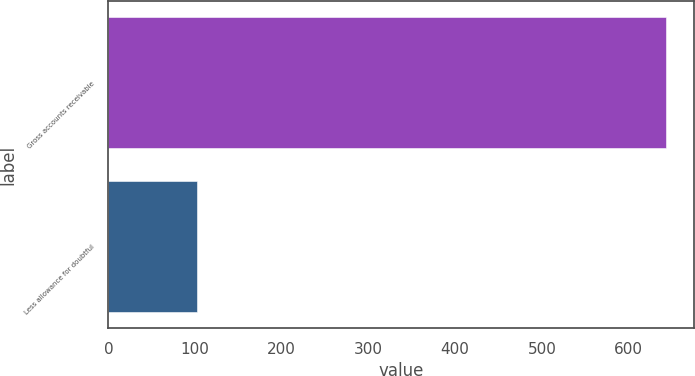Convert chart to OTSL. <chart><loc_0><loc_0><loc_500><loc_500><bar_chart><fcel>Gross accounts receivable<fcel>Less allowance for doubtful<nl><fcel>643.6<fcel>102.3<nl></chart> 